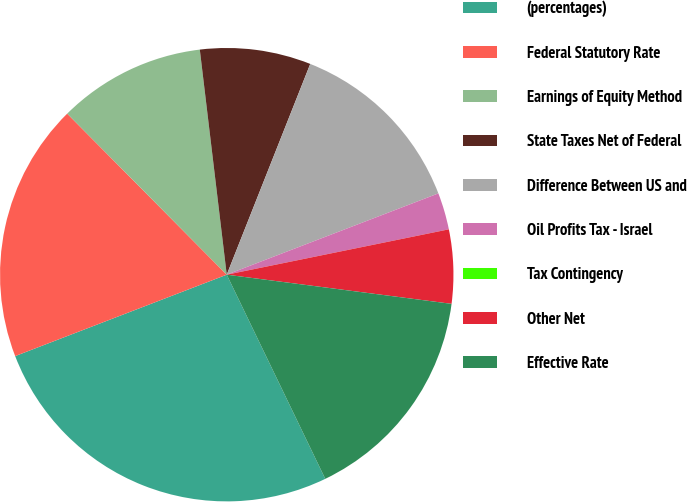Convert chart to OTSL. <chart><loc_0><loc_0><loc_500><loc_500><pie_chart><fcel>(percentages)<fcel>Federal Statutory Rate<fcel>Earnings of Equity Method<fcel>State Taxes Net of Federal<fcel>Difference Between US and<fcel>Oil Profits Tax - Israel<fcel>Tax Contingency<fcel>Other Net<fcel>Effective Rate<nl><fcel>26.31%<fcel>18.42%<fcel>10.53%<fcel>7.9%<fcel>13.16%<fcel>2.63%<fcel>0.0%<fcel>5.26%<fcel>15.79%<nl></chart> 